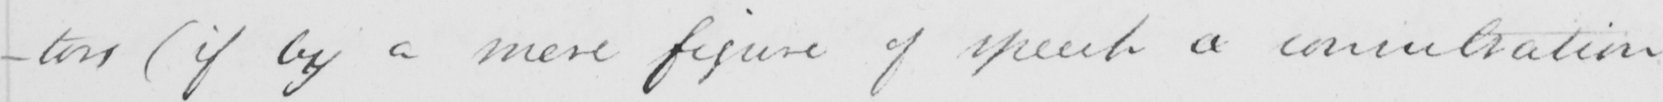What is written in this line of handwriting? -tors  ( if by a mere figure of speech a concentration 